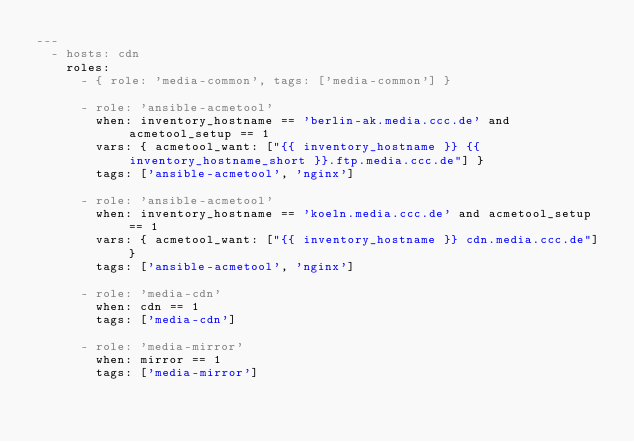Convert code to text. <code><loc_0><loc_0><loc_500><loc_500><_YAML_>---
  - hosts: cdn
    roles:
      - { role: 'media-common', tags: ['media-common'] }

      - role: 'ansible-acmetool'
        when: inventory_hostname == 'berlin-ak.media.ccc.de' and acmetool_setup == 1
        vars: { acmetool_want: ["{{ inventory_hostname }} {{ inventory_hostname_short }}.ftp.media.ccc.de"] }
        tags: ['ansible-acmetool', 'nginx']

      - role: 'ansible-acmetool'
        when: inventory_hostname == 'koeln.media.ccc.de' and acmetool_setup == 1
        vars: { acmetool_want: ["{{ inventory_hostname }} cdn.media.ccc.de"] }
        tags: ['ansible-acmetool', 'nginx']

      - role: 'media-cdn'
        when: cdn == 1
        tags: ['media-cdn']

      - role: 'media-mirror'
        when: mirror == 1
        tags: ['media-mirror']
</code> 